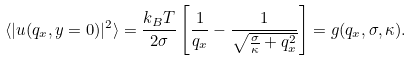Convert formula to latex. <formula><loc_0><loc_0><loc_500><loc_500>\langle | u ( q _ { x } , y = 0 ) | ^ { 2 } \rangle = \frac { k _ { B } T } { 2 \sigma } \left [ \frac { 1 } { q _ { x } } - \frac { 1 } { \sqrt { \frac { \sigma } { \kappa } + q _ { x } ^ { 2 } } } \right ] = g ( q _ { x } , \sigma , \kappa ) .</formula> 